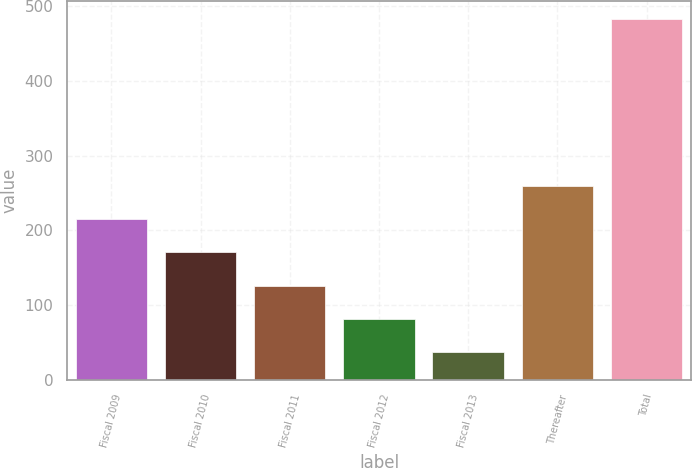Convert chart to OTSL. <chart><loc_0><loc_0><loc_500><loc_500><bar_chart><fcel>Fiscal 2009<fcel>Fiscal 2010<fcel>Fiscal 2011<fcel>Fiscal 2012<fcel>Fiscal 2013<fcel>Thereafter<fcel>Total<nl><fcel>215.4<fcel>170.8<fcel>126.2<fcel>81.6<fcel>37<fcel>260<fcel>483<nl></chart> 